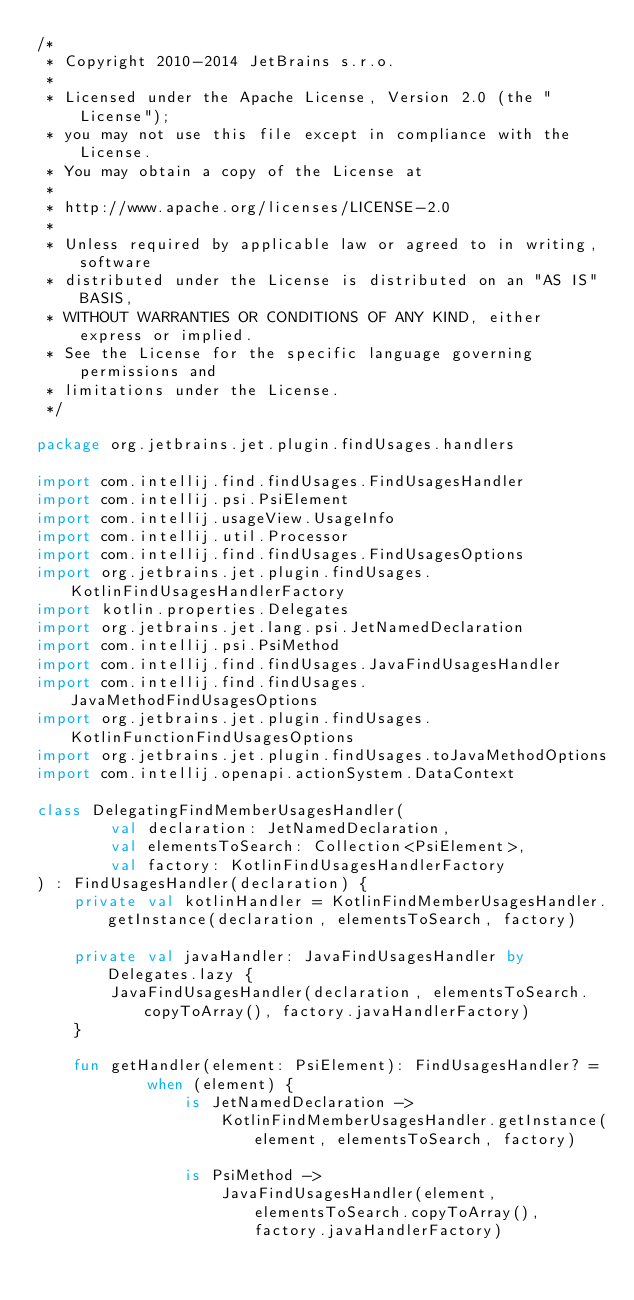Convert code to text. <code><loc_0><loc_0><loc_500><loc_500><_Kotlin_>/*
 * Copyright 2010-2014 JetBrains s.r.o.
 *
 * Licensed under the Apache License, Version 2.0 (the "License");
 * you may not use this file except in compliance with the License.
 * You may obtain a copy of the License at
 *
 * http://www.apache.org/licenses/LICENSE-2.0
 *
 * Unless required by applicable law or agreed to in writing, software
 * distributed under the License is distributed on an "AS IS" BASIS,
 * WITHOUT WARRANTIES OR CONDITIONS OF ANY KIND, either express or implied.
 * See the License for the specific language governing permissions and
 * limitations under the License.
 */

package org.jetbrains.jet.plugin.findUsages.handlers

import com.intellij.find.findUsages.FindUsagesHandler
import com.intellij.psi.PsiElement
import com.intellij.usageView.UsageInfo
import com.intellij.util.Processor
import com.intellij.find.findUsages.FindUsagesOptions
import org.jetbrains.jet.plugin.findUsages.KotlinFindUsagesHandlerFactory
import kotlin.properties.Delegates
import org.jetbrains.jet.lang.psi.JetNamedDeclaration
import com.intellij.psi.PsiMethod
import com.intellij.find.findUsages.JavaFindUsagesHandler
import com.intellij.find.findUsages.JavaMethodFindUsagesOptions
import org.jetbrains.jet.plugin.findUsages.KotlinFunctionFindUsagesOptions
import org.jetbrains.jet.plugin.findUsages.toJavaMethodOptions
import com.intellij.openapi.actionSystem.DataContext

class DelegatingFindMemberUsagesHandler(
        val declaration: JetNamedDeclaration,
        val elementsToSearch: Collection<PsiElement>,
        val factory: KotlinFindUsagesHandlerFactory
) : FindUsagesHandler(declaration) {
    private val kotlinHandler = KotlinFindMemberUsagesHandler.getInstance(declaration, elementsToSearch, factory)

    private val javaHandler: JavaFindUsagesHandler by Delegates.lazy {
        JavaFindUsagesHandler(declaration, elementsToSearch.copyToArray(), factory.javaHandlerFactory)
    }

    fun getHandler(element: PsiElement): FindUsagesHandler? =
            when (element) {
                is JetNamedDeclaration ->
                    KotlinFindMemberUsagesHandler.getInstance(element, elementsToSearch, factory)

                is PsiMethod ->
                    JavaFindUsagesHandler(element, elementsToSearch.copyToArray(), factory.javaHandlerFactory)
</code> 